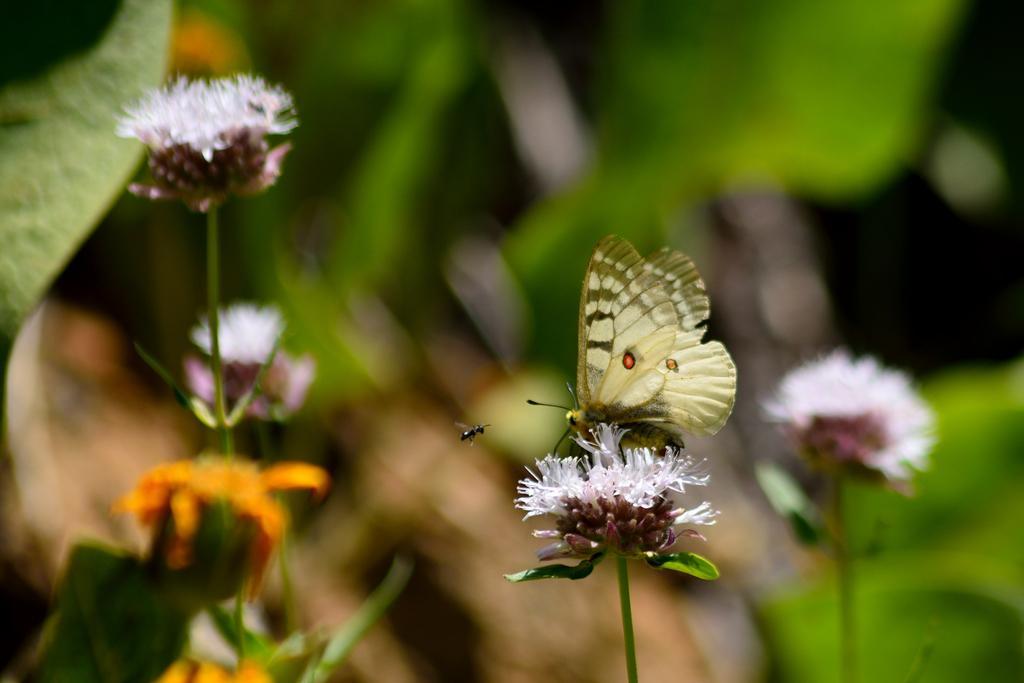In one or two sentences, can you explain what this image depicts? In this image butterfly is on the flower. An insect is flying in the air. Left side there are few flowers and leaves. Right bottom there is a flower. Background is blurry. 